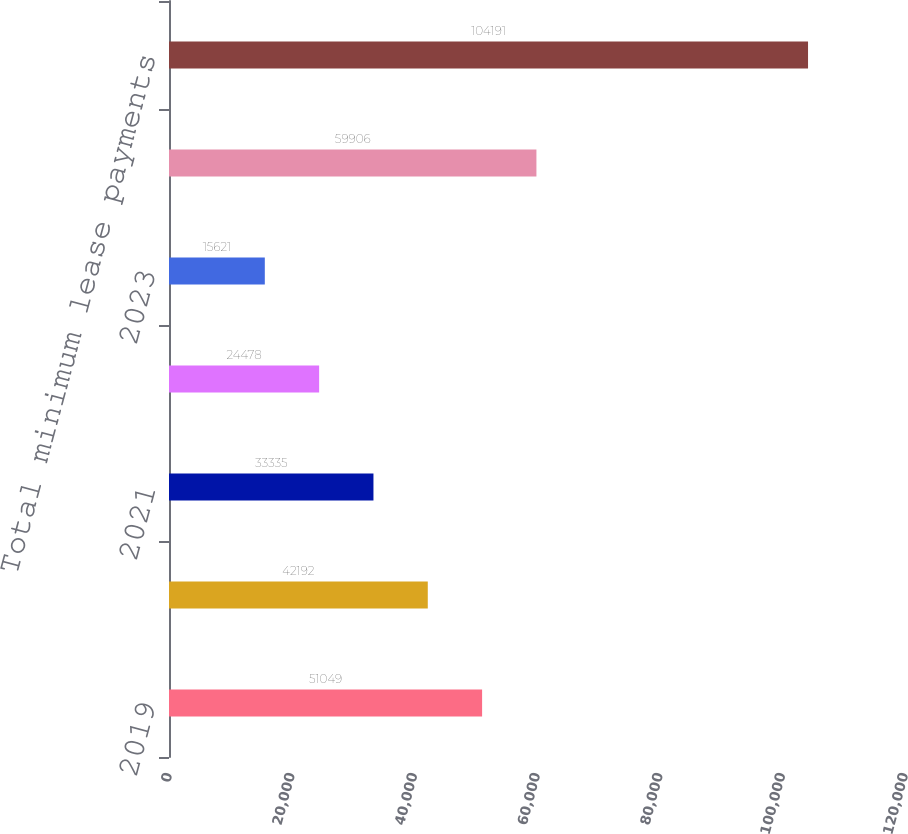<chart> <loc_0><loc_0><loc_500><loc_500><bar_chart><fcel>2019<fcel>2020<fcel>2021<fcel>2022<fcel>2023<fcel>Thereafter<fcel>Total minimum lease payments<nl><fcel>51049<fcel>42192<fcel>33335<fcel>24478<fcel>15621<fcel>59906<fcel>104191<nl></chart> 